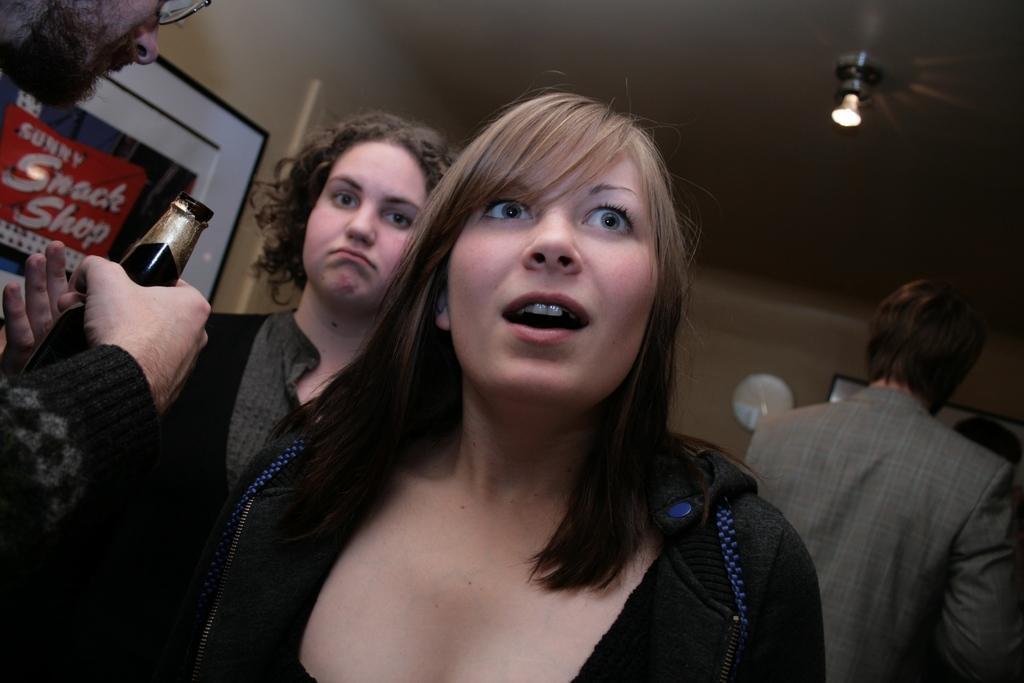Could you give a brief overview of what you see in this image? In this image I can see group of people. In front the person is wearing black color dress and the person at left is holding the bottle. In the background I can see the few frames attached to the wall and the wall is in brown color and I can also see the light. 